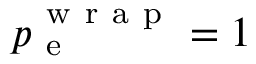<formula> <loc_0><loc_0><loc_500><loc_500>p _ { e } ^ { w r a p } = 1</formula> 